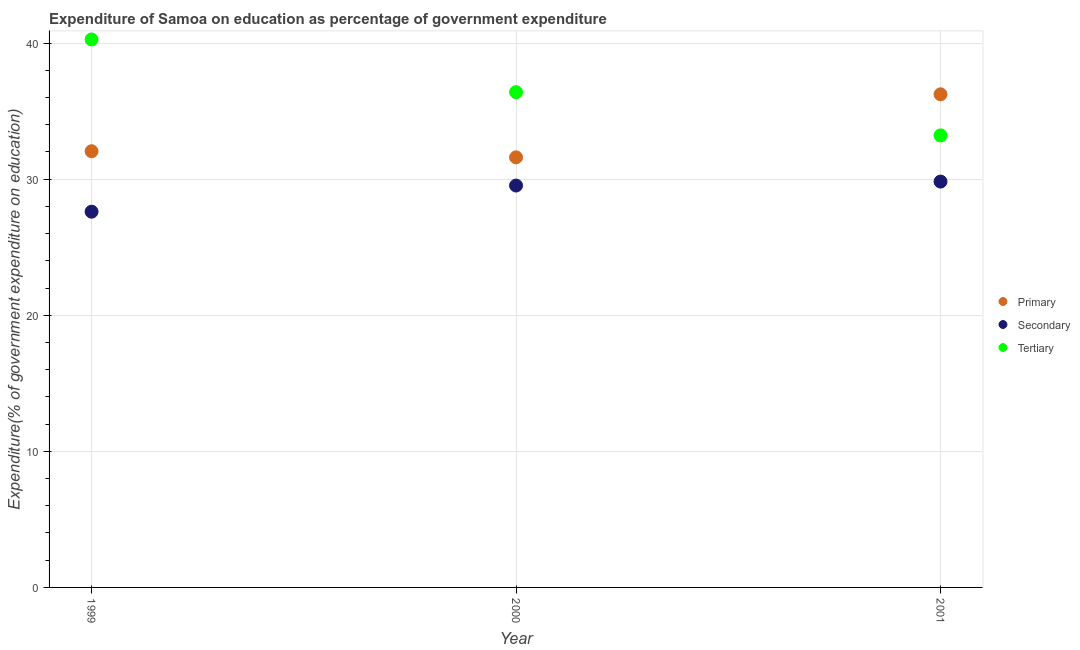How many different coloured dotlines are there?
Your response must be concise. 3. Is the number of dotlines equal to the number of legend labels?
Ensure brevity in your answer.  Yes. What is the expenditure on primary education in 2001?
Ensure brevity in your answer.  36.24. Across all years, what is the maximum expenditure on secondary education?
Keep it short and to the point. 29.82. Across all years, what is the minimum expenditure on tertiary education?
Offer a terse response. 33.22. In which year was the expenditure on primary education maximum?
Give a very brief answer. 2001. What is the total expenditure on tertiary education in the graph?
Make the answer very short. 109.89. What is the difference between the expenditure on tertiary education in 1999 and that in 2000?
Provide a short and direct response. 3.87. What is the difference between the expenditure on secondary education in 2001 and the expenditure on primary education in 1999?
Your answer should be very brief. -2.23. What is the average expenditure on primary education per year?
Give a very brief answer. 33.3. In the year 2001, what is the difference between the expenditure on tertiary education and expenditure on primary education?
Provide a short and direct response. -3.02. In how many years, is the expenditure on primary education greater than 34 %?
Give a very brief answer. 1. What is the ratio of the expenditure on tertiary education in 1999 to that in 2000?
Your answer should be very brief. 1.11. Is the expenditure on primary education in 2000 less than that in 2001?
Your answer should be compact. Yes. What is the difference between the highest and the second highest expenditure on primary education?
Provide a succinct answer. 4.18. What is the difference between the highest and the lowest expenditure on tertiary education?
Provide a short and direct response. 7.05. Is it the case that in every year, the sum of the expenditure on primary education and expenditure on secondary education is greater than the expenditure on tertiary education?
Ensure brevity in your answer.  Yes. How many dotlines are there?
Make the answer very short. 3. Does the graph contain grids?
Provide a succinct answer. Yes. Where does the legend appear in the graph?
Provide a succinct answer. Center right. How many legend labels are there?
Your answer should be very brief. 3. What is the title of the graph?
Offer a terse response. Expenditure of Samoa on education as percentage of government expenditure. Does "Ages 60+" appear as one of the legend labels in the graph?
Your answer should be very brief. No. What is the label or title of the X-axis?
Provide a succinct answer. Year. What is the label or title of the Y-axis?
Ensure brevity in your answer.  Expenditure(% of government expenditure on education). What is the Expenditure(% of government expenditure on education) of Primary in 1999?
Your answer should be compact. 32.05. What is the Expenditure(% of government expenditure on education) of Secondary in 1999?
Ensure brevity in your answer.  27.61. What is the Expenditure(% of government expenditure on education) of Tertiary in 1999?
Keep it short and to the point. 40.27. What is the Expenditure(% of government expenditure on education) of Primary in 2000?
Your answer should be very brief. 31.61. What is the Expenditure(% of government expenditure on education) of Secondary in 2000?
Your answer should be compact. 29.53. What is the Expenditure(% of government expenditure on education) of Tertiary in 2000?
Offer a very short reply. 36.4. What is the Expenditure(% of government expenditure on education) in Primary in 2001?
Make the answer very short. 36.24. What is the Expenditure(% of government expenditure on education) in Secondary in 2001?
Give a very brief answer. 29.82. What is the Expenditure(% of government expenditure on education) in Tertiary in 2001?
Provide a succinct answer. 33.22. Across all years, what is the maximum Expenditure(% of government expenditure on education) of Primary?
Your response must be concise. 36.24. Across all years, what is the maximum Expenditure(% of government expenditure on education) of Secondary?
Offer a terse response. 29.82. Across all years, what is the maximum Expenditure(% of government expenditure on education) in Tertiary?
Provide a succinct answer. 40.27. Across all years, what is the minimum Expenditure(% of government expenditure on education) in Primary?
Make the answer very short. 31.61. Across all years, what is the minimum Expenditure(% of government expenditure on education) in Secondary?
Your answer should be very brief. 27.61. Across all years, what is the minimum Expenditure(% of government expenditure on education) of Tertiary?
Your answer should be compact. 33.22. What is the total Expenditure(% of government expenditure on education) of Primary in the graph?
Offer a very short reply. 99.9. What is the total Expenditure(% of government expenditure on education) in Secondary in the graph?
Offer a terse response. 86.97. What is the total Expenditure(% of government expenditure on education) of Tertiary in the graph?
Your response must be concise. 109.89. What is the difference between the Expenditure(% of government expenditure on education) of Primary in 1999 and that in 2000?
Offer a very short reply. 0.45. What is the difference between the Expenditure(% of government expenditure on education) of Secondary in 1999 and that in 2000?
Offer a terse response. -1.92. What is the difference between the Expenditure(% of government expenditure on education) in Tertiary in 1999 and that in 2000?
Your answer should be very brief. 3.87. What is the difference between the Expenditure(% of government expenditure on education) in Primary in 1999 and that in 2001?
Give a very brief answer. -4.18. What is the difference between the Expenditure(% of government expenditure on education) of Secondary in 1999 and that in 2001?
Offer a terse response. -2.21. What is the difference between the Expenditure(% of government expenditure on education) of Tertiary in 1999 and that in 2001?
Provide a succinct answer. 7.05. What is the difference between the Expenditure(% of government expenditure on education) in Primary in 2000 and that in 2001?
Provide a succinct answer. -4.63. What is the difference between the Expenditure(% of government expenditure on education) in Secondary in 2000 and that in 2001?
Your answer should be very brief. -0.29. What is the difference between the Expenditure(% of government expenditure on education) of Tertiary in 2000 and that in 2001?
Ensure brevity in your answer.  3.18. What is the difference between the Expenditure(% of government expenditure on education) in Primary in 1999 and the Expenditure(% of government expenditure on education) in Secondary in 2000?
Ensure brevity in your answer.  2.52. What is the difference between the Expenditure(% of government expenditure on education) in Primary in 1999 and the Expenditure(% of government expenditure on education) in Tertiary in 2000?
Your response must be concise. -4.34. What is the difference between the Expenditure(% of government expenditure on education) in Secondary in 1999 and the Expenditure(% of government expenditure on education) in Tertiary in 2000?
Keep it short and to the point. -8.78. What is the difference between the Expenditure(% of government expenditure on education) of Primary in 1999 and the Expenditure(% of government expenditure on education) of Secondary in 2001?
Give a very brief answer. 2.23. What is the difference between the Expenditure(% of government expenditure on education) of Primary in 1999 and the Expenditure(% of government expenditure on education) of Tertiary in 2001?
Make the answer very short. -1.16. What is the difference between the Expenditure(% of government expenditure on education) of Secondary in 1999 and the Expenditure(% of government expenditure on education) of Tertiary in 2001?
Provide a short and direct response. -5.61. What is the difference between the Expenditure(% of government expenditure on education) of Primary in 2000 and the Expenditure(% of government expenditure on education) of Secondary in 2001?
Provide a short and direct response. 1.78. What is the difference between the Expenditure(% of government expenditure on education) in Primary in 2000 and the Expenditure(% of government expenditure on education) in Tertiary in 2001?
Keep it short and to the point. -1.61. What is the difference between the Expenditure(% of government expenditure on education) in Secondary in 2000 and the Expenditure(% of government expenditure on education) in Tertiary in 2001?
Your answer should be very brief. -3.69. What is the average Expenditure(% of government expenditure on education) of Primary per year?
Provide a short and direct response. 33.3. What is the average Expenditure(% of government expenditure on education) in Secondary per year?
Provide a succinct answer. 28.99. What is the average Expenditure(% of government expenditure on education) of Tertiary per year?
Give a very brief answer. 36.63. In the year 1999, what is the difference between the Expenditure(% of government expenditure on education) of Primary and Expenditure(% of government expenditure on education) of Secondary?
Provide a succinct answer. 4.44. In the year 1999, what is the difference between the Expenditure(% of government expenditure on education) of Primary and Expenditure(% of government expenditure on education) of Tertiary?
Keep it short and to the point. -8.22. In the year 1999, what is the difference between the Expenditure(% of government expenditure on education) of Secondary and Expenditure(% of government expenditure on education) of Tertiary?
Offer a very short reply. -12.66. In the year 2000, what is the difference between the Expenditure(% of government expenditure on education) of Primary and Expenditure(% of government expenditure on education) of Secondary?
Give a very brief answer. 2.07. In the year 2000, what is the difference between the Expenditure(% of government expenditure on education) in Primary and Expenditure(% of government expenditure on education) in Tertiary?
Offer a very short reply. -4.79. In the year 2000, what is the difference between the Expenditure(% of government expenditure on education) of Secondary and Expenditure(% of government expenditure on education) of Tertiary?
Your answer should be very brief. -6.86. In the year 2001, what is the difference between the Expenditure(% of government expenditure on education) in Primary and Expenditure(% of government expenditure on education) in Secondary?
Your answer should be very brief. 6.41. In the year 2001, what is the difference between the Expenditure(% of government expenditure on education) in Primary and Expenditure(% of government expenditure on education) in Tertiary?
Your answer should be very brief. 3.02. In the year 2001, what is the difference between the Expenditure(% of government expenditure on education) of Secondary and Expenditure(% of government expenditure on education) of Tertiary?
Keep it short and to the point. -3.39. What is the ratio of the Expenditure(% of government expenditure on education) in Primary in 1999 to that in 2000?
Offer a terse response. 1.01. What is the ratio of the Expenditure(% of government expenditure on education) in Secondary in 1999 to that in 2000?
Provide a succinct answer. 0.93. What is the ratio of the Expenditure(% of government expenditure on education) of Tertiary in 1999 to that in 2000?
Keep it short and to the point. 1.11. What is the ratio of the Expenditure(% of government expenditure on education) of Primary in 1999 to that in 2001?
Offer a very short reply. 0.88. What is the ratio of the Expenditure(% of government expenditure on education) in Secondary in 1999 to that in 2001?
Give a very brief answer. 0.93. What is the ratio of the Expenditure(% of government expenditure on education) of Tertiary in 1999 to that in 2001?
Your response must be concise. 1.21. What is the ratio of the Expenditure(% of government expenditure on education) of Primary in 2000 to that in 2001?
Your response must be concise. 0.87. What is the ratio of the Expenditure(% of government expenditure on education) of Secondary in 2000 to that in 2001?
Your answer should be compact. 0.99. What is the ratio of the Expenditure(% of government expenditure on education) of Tertiary in 2000 to that in 2001?
Your answer should be very brief. 1.1. What is the difference between the highest and the second highest Expenditure(% of government expenditure on education) in Primary?
Give a very brief answer. 4.18. What is the difference between the highest and the second highest Expenditure(% of government expenditure on education) of Secondary?
Your response must be concise. 0.29. What is the difference between the highest and the second highest Expenditure(% of government expenditure on education) of Tertiary?
Provide a succinct answer. 3.87. What is the difference between the highest and the lowest Expenditure(% of government expenditure on education) in Primary?
Offer a very short reply. 4.63. What is the difference between the highest and the lowest Expenditure(% of government expenditure on education) in Secondary?
Your response must be concise. 2.21. What is the difference between the highest and the lowest Expenditure(% of government expenditure on education) in Tertiary?
Provide a short and direct response. 7.05. 